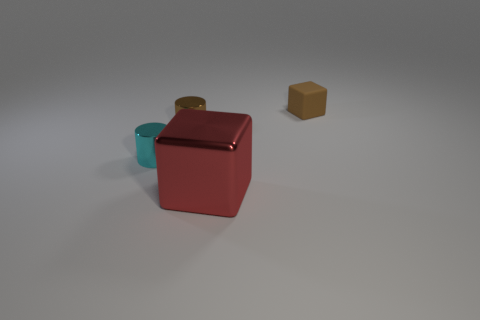Is the number of small brown shiny cylinders that are in front of the brown cylinder the same as the number of tiny metal things that are to the right of the large red block?
Give a very brief answer. Yes. There is a cyan thing that is left of the big red metal thing; does it have the same shape as the red metallic thing?
Provide a short and direct response. No. What number of red objects are matte objects or metallic balls?
Make the answer very short. 0. There is a small brown thing that is the same shape as the big red object; what is its material?
Your answer should be compact. Rubber. There is a brown thing to the left of the brown cube; what is its shape?
Give a very brief answer. Cylinder. Are there any red cylinders that have the same material as the small brown block?
Give a very brief answer. No. Is the brown cylinder the same size as the cyan shiny cylinder?
Your response must be concise. Yes. How many cylinders are either cyan things or metal objects?
Keep it short and to the point. 2. There is a tiny cylinder that is the same color as the matte object; what material is it?
Provide a short and direct response. Metal. How many other objects have the same shape as the red object?
Provide a succinct answer. 1. 